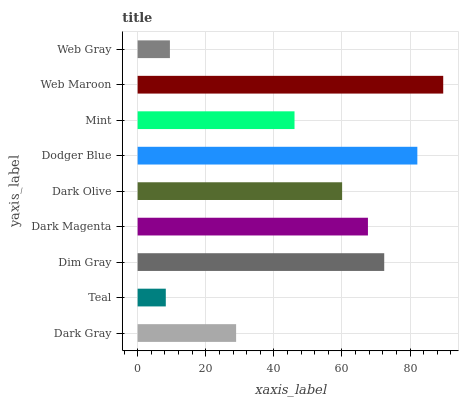Is Teal the minimum?
Answer yes or no. Yes. Is Web Maroon the maximum?
Answer yes or no. Yes. Is Dim Gray the minimum?
Answer yes or no. No. Is Dim Gray the maximum?
Answer yes or no. No. Is Dim Gray greater than Teal?
Answer yes or no. Yes. Is Teal less than Dim Gray?
Answer yes or no. Yes. Is Teal greater than Dim Gray?
Answer yes or no. No. Is Dim Gray less than Teal?
Answer yes or no. No. Is Dark Olive the high median?
Answer yes or no. Yes. Is Dark Olive the low median?
Answer yes or no. Yes. Is Dodger Blue the high median?
Answer yes or no. No. Is Dim Gray the low median?
Answer yes or no. No. 